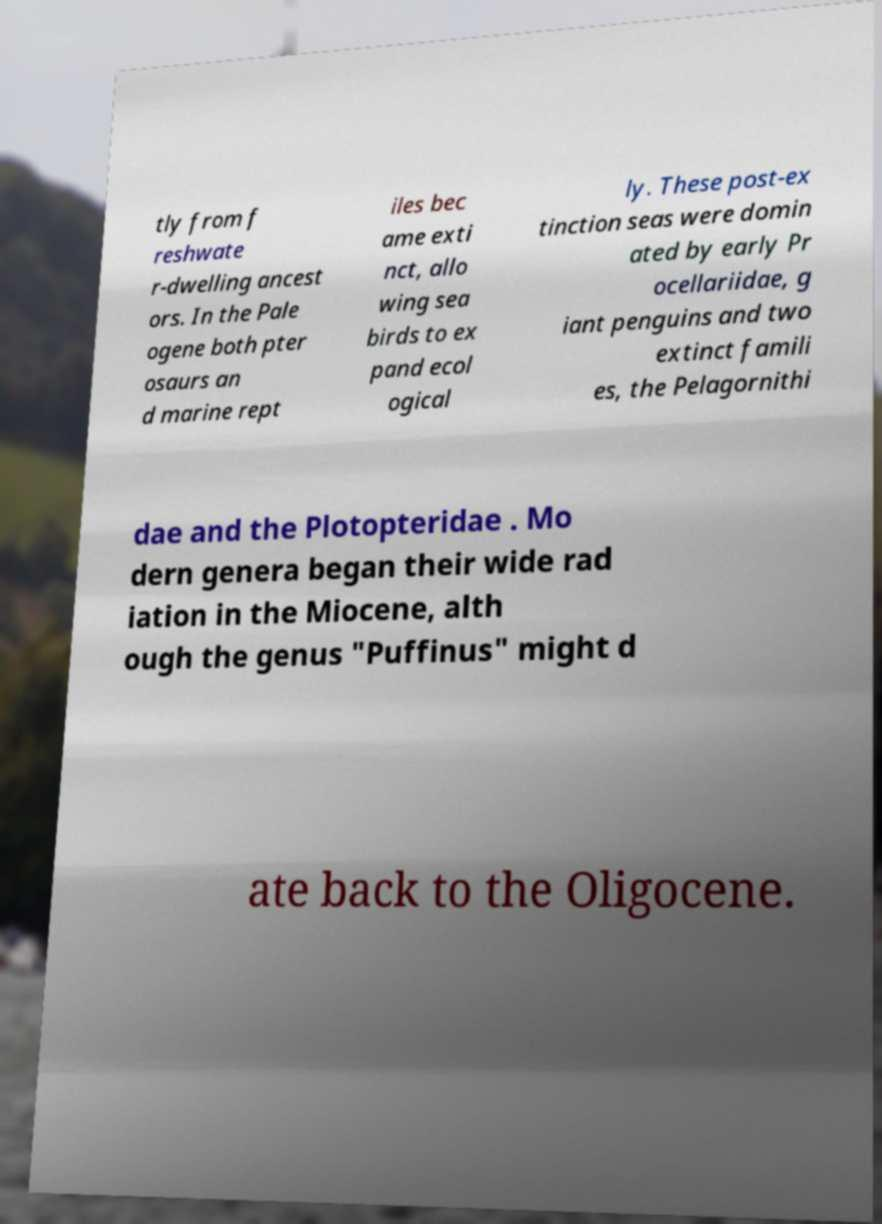Please identify and transcribe the text found in this image. tly from f reshwate r-dwelling ancest ors. In the Pale ogene both pter osaurs an d marine rept iles bec ame exti nct, allo wing sea birds to ex pand ecol ogical ly. These post-ex tinction seas were domin ated by early Pr ocellariidae, g iant penguins and two extinct famili es, the Pelagornithi dae and the Plotopteridae . Mo dern genera began their wide rad iation in the Miocene, alth ough the genus "Puffinus" might d ate back to the Oligocene. 